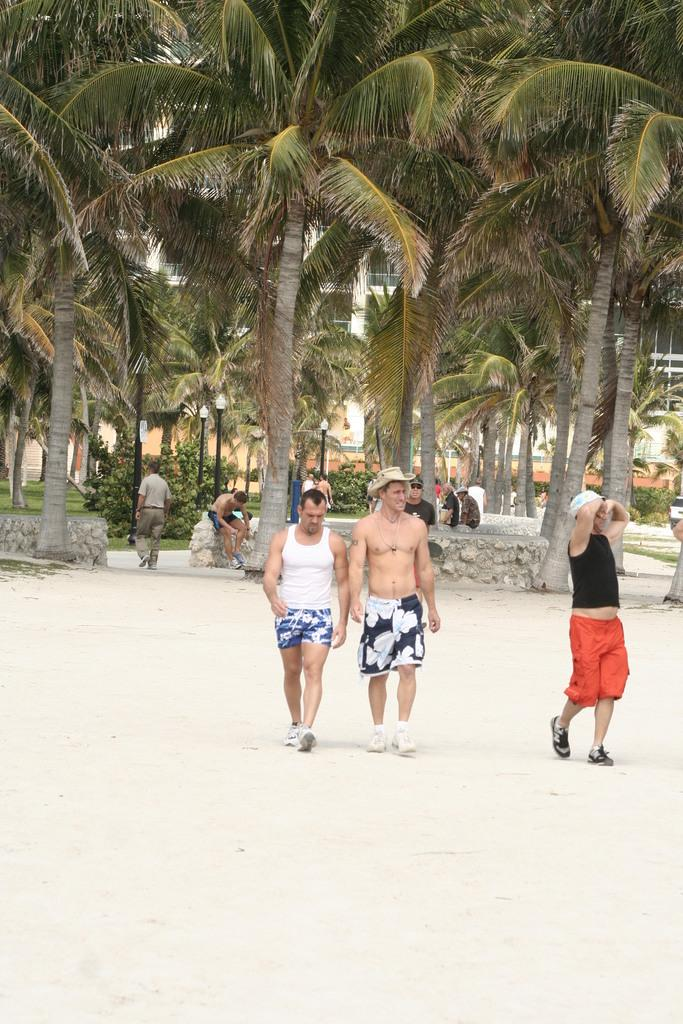What are the three persons in the image doing? The three persons are walking in the image. What can be seen in the background of the image? Walls, plants, trees, other persons, poles with lights, and a building are visible in the background. How many persons can be seen in total in the image? There are at least three persons walking and other persons visible in the background, so there are more than three persons in the image. What type of elbow is visible on the person in the image? There is no mention of an elbow or any body part in the provided facts, so it cannot be determined from the image. Can you tell me what animals are present in the zoo in the image? There is no mention of a zoo or any animals in the provided facts, so it cannot be determined from the image. 